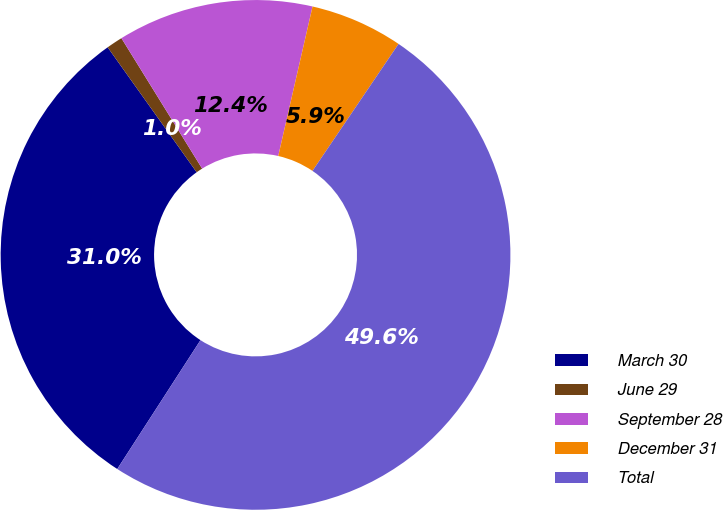Convert chart. <chart><loc_0><loc_0><loc_500><loc_500><pie_chart><fcel>March 30<fcel>June 29<fcel>September 28<fcel>December 31<fcel>Total<nl><fcel>31.02%<fcel>1.03%<fcel>12.41%<fcel>5.89%<fcel>49.64%<nl></chart> 